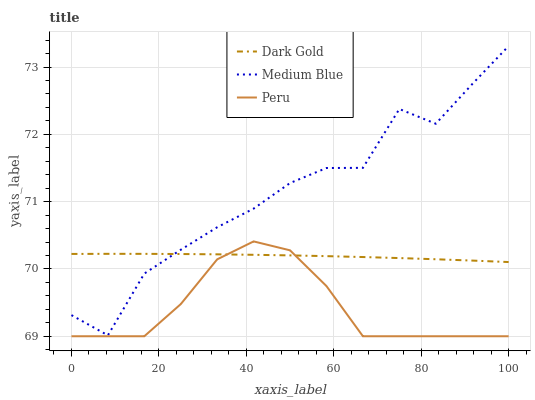Does Peru have the minimum area under the curve?
Answer yes or no. Yes. Does Medium Blue have the maximum area under the curve?
Answer yes or no. Yes. Does Dark Gold have the minimum area under the curve?
Answer yes or no. No. Does Dark Gold have the maximum area under the curve?
Answer yes or no. No. Is Dark Gold the smoothest?
Answer yes or no. Yes. Is Medium Blue the roughest?
Answer yes or no. Yes. Is Peru the smoothest?
Answer yes or no. No. Is Peru the roughest?
Answer yes or no. No. Does Peru have the lowest value?
Answer yes or no. Yes. Does Dark Gold have the lowest value?
Answer yes or no. No. Does Medium Blue have the highest value?
Answer yes or no. Yes. Does Peru have the highest value?
Answer yes or no. No. Is Peru less than Medium Blue?
Answer yes or no. Yes. Is Medium Blue greater than Peru?
Answer yes or no. Yes. Does Dark Gold intersect Peru?
Answer yes or no. Yes. Is Dark Gold less than Peru?
Answer yes or no. No. Is Dark Gold greater than Peru?
Answer yes or no. No. Does Peru intersect Medium Blue?
Answer yes or no. No. 